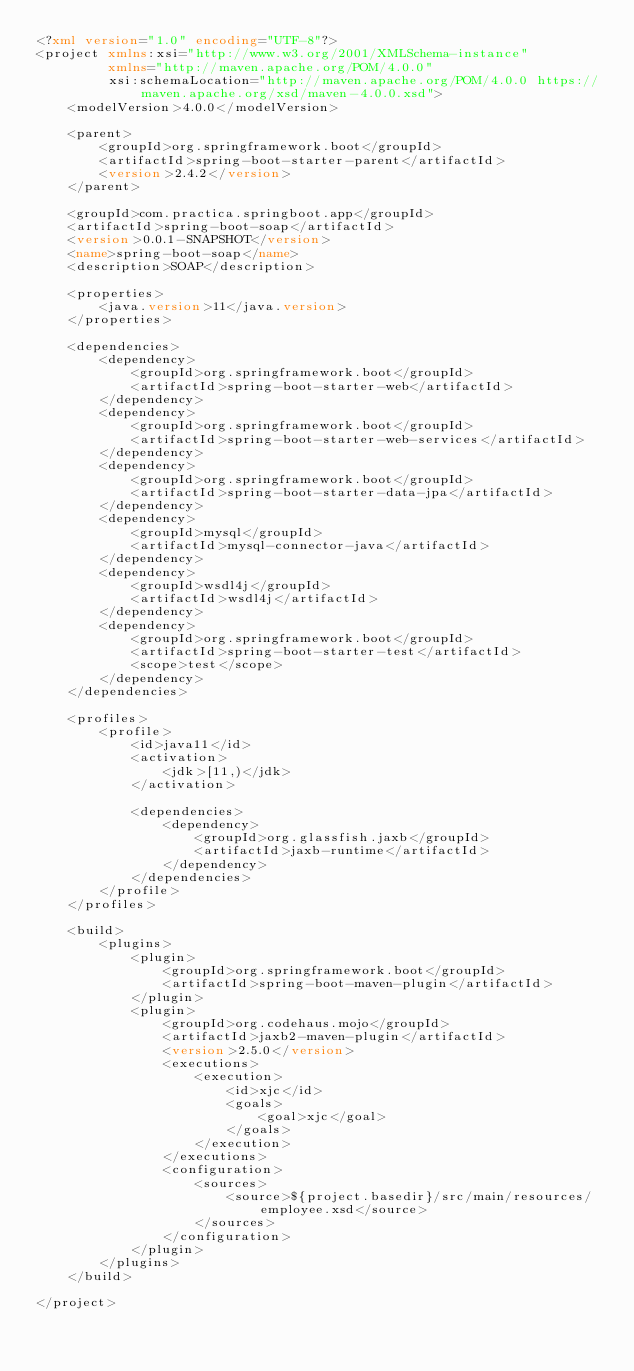<code> <loc_0><loc_0><loc_500><loc_500><_XML_><?xml version="1.0" encoding="UTF-8"?>
<project xmlns:xsi="http://www.w3.org/2001/XMLSchema-instance"
         xmlns="http://maven.apache.org/POM/4.0.0"
         xsi:schemaLocation="http://maven.apache.org/POM/4.0.0 https://maven.apache.org/xsd/maven-4.0.0.xsd">
    <modelVersion>4.0.0</modelVersion>

    <parent>
        <groupId>org.springframework.boot</groupId>
        <artifactId>spring-boot-starter-parent</artifactId>
        <version>2.4.2</version>
    </parent>

    <groupId>com.practica.springboot.app</groupId>
    <artifactId>spring-boot-soap</artifactId>
    <version>0.0.1-SNAPSHOT</version>
    <name>spring-boot-soap</name>
    <description>SOAP</description>

    <properties>
        <java.version>11</java.version>
    </properties>

    <dependencies>
        <dependency>
            <groupId>org.springframework.boot</groupId>
            <artifactId>spring-boot-starter-web</artifactId>
        </dependency>
        <dependency>
            <groupId>org.springframework.boot</groupId>
            <artifactId>spring-boot-starter-web-services</artifactId>
        </dependency>
        <dependency>
            <groupId>org.springframework.boot</groupId>
            <artifactId>spring-boot-starter-data-jpa</artifactId>
        </dependency>
        <dependency>
            <groupId>mysql</groupId>
            <artifactId>mysql-connector-java</artifactId>
        </dependency>
        <dependency>
            <groupId>wsdl4j</groupId>
            <artifactId>wsdl4j</artifactId>
        </dependency>
        <dependency>
            <groupId>org.springframework.boot</groupId>
            <artifactId>spring-boot-starter-test</artifactId>
            <scope>test</scope>
        </dependency>
    </dependencies>

    <profiles>
        <profile>
            <id>java11</id>
            <activation>
                <jdk>[11,)</jdk>
            </activation>

            <dependencies>
                <dependency>
                    <groupId>org.glassfish.jaxb</groupId>
                    <artifactId>jaxb-runtime</artifactId>
                </dependency>
            </dependencies>
        </profile>
    </profiles>

    <build>
        <plugins>
            <plugin>
                <groupId>org.springframework.boot</groupId>
                <artifactId>spring-boot-maven-plugin</artifactId>
            </plugin>
            <plugin>
                <groupId>org.codehaus.mojo</groupId>
                <artifactId>jaxb2-maven-plugin</artifactId>
                <version>2.5.0</version>
                <executions>
                    <execution>
                        <id>xjc</id>
                        <goals>
                            <goal>xjc</goal>
                        </goals>
                    </execution>
                </executions>
                <configuration>
                    <sources>
                        <source>${project.basedir}/src/main/resources/employee.xsd</source>
                    </sources>
                </configuration>
            </plugin>
        </plugins>
    </build>

</project></code> 